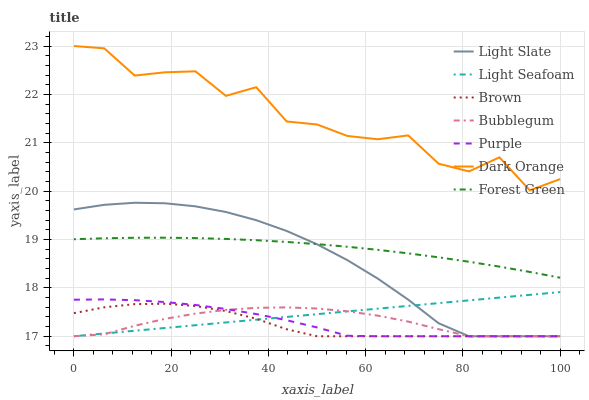Does Brown have the minimum area under the curve?
Answer yes or no. Yes. Does Dark Orange have the maximum area under the curve?
Answer yes or no. Yes. Does Light Slate have the minimum area under the curve?
Answer yes or no. No. Does Light Slate have the maximum area under the curve?
Answer yes or no. No. Is Light Seafoam the smoothest?
Answer yes or no. Yes. Is Dark Orange the roughest?
Answer yes or no. Yes. Is Light Slate the smoothest?
Answer yes or no. No. Is Light Slate the roughest?
Answer yes or no. No. Does Brown have the lowest value?
Answer yes or no. Yes. Does Dark Orange have the lowest value?
Answer yes or no. No. Does Dark Orange have the highest value?
Answer yes or no. Yes. Does Light Slate have the highest value?
Answer yes or no. No. Is Bubblegum less than Forest Green?
Answer yes or no. Yes. Is Dark Orange greater than Forest Green?
Answer yes or no. Yes. Does Light Seafoam intersect Purple?
Answer yes or no. Yes. Is Light Seafoam less than Purple?
Answer yes or no. No. Is Light Seafoam greater than Purple?
Answer yes or no. No. Does Bubblegum intersect Forest Green?
Answer yes or no. No. 